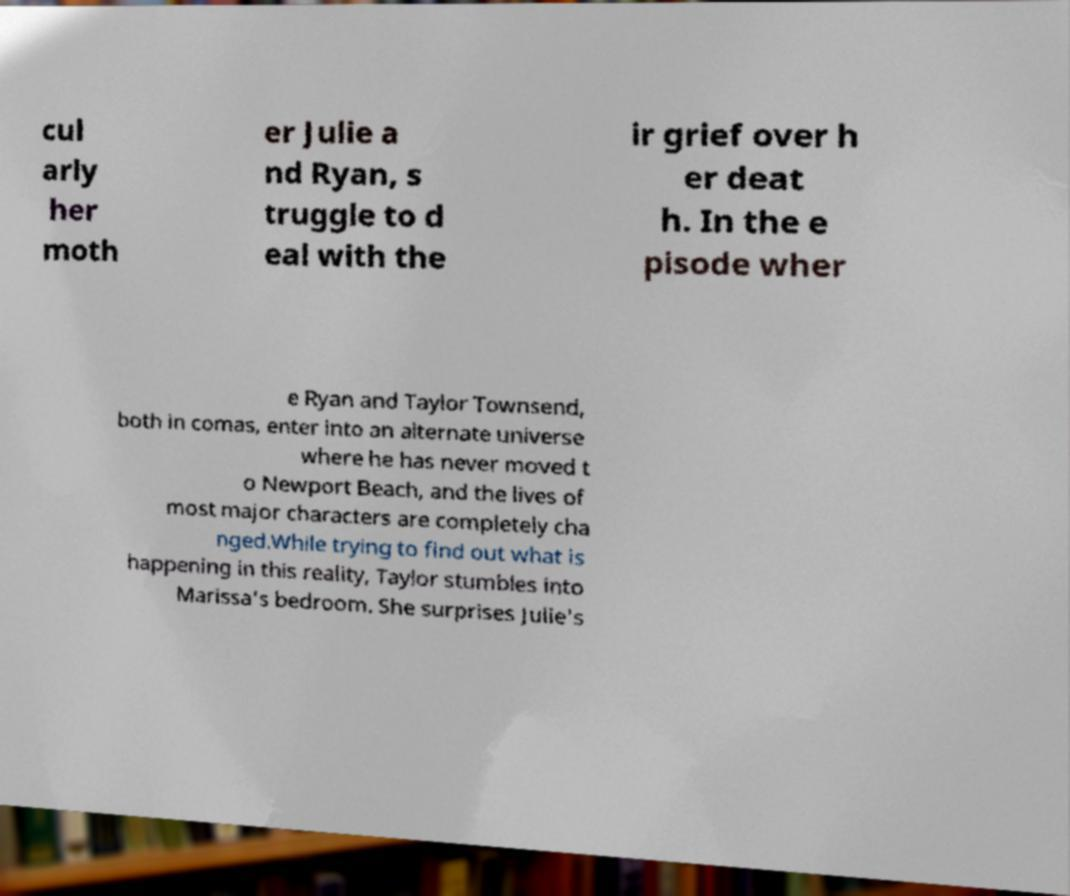There's text embedded in this image that I need extracted. Can you transcribe it verbatim? cul arly her moth er Julie a nd Ryan, s truggle to d eal with the ir grief over h er deat h. In the e pisode wher e Ryan and Taylor Townsend, both in comas, enter into an alternate universe where he has never moved t o Newport Beach, and the lives of most major characters are completely cha nged.While trying to find out what is happening in this reality, Taylor stumbles into Marissa's bedroom. She surprises Julie's 